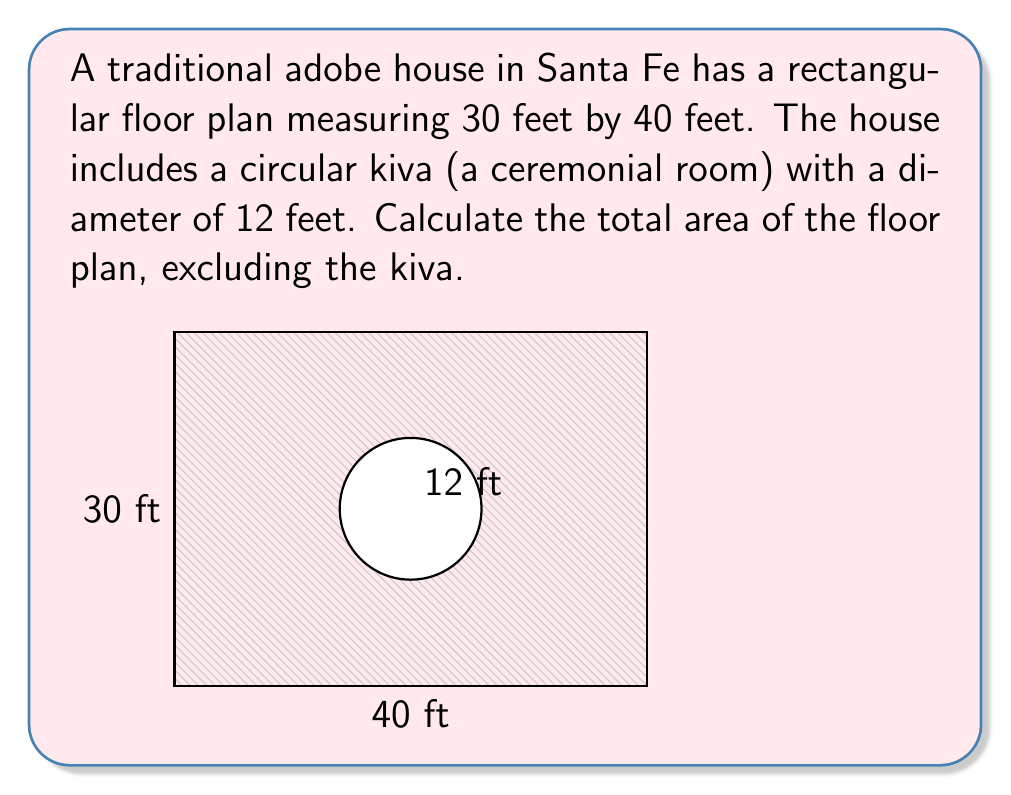Solve this math problem. To solve this problem, we'll follow these steps:

1) Calculate the total area of the rectangular floor plan:
   $$A_{rectangle} = length \times width = 40 \text{ ft} \times 30 \text{ ft} = 1200 \text{ sq ft}$$

2) Calculate the area of the circular kiva:
   $$A_{circle} = \pi r^2$$
   where $r$ is the radius, which is half the diameter.
   $$r = 12 \text{ ft} \div 2 = 6 \text{ ft}$$
   $$A_{circle} = \pi (6 \text{ ft})^2 = 36\pi \text{ sq ft} \approx 113.10 \text{ sq ft}$$

3) Subtract the area of the kiva from the total rectangular area:
   $$A_{total} = A_{rectangle} - A_{circle}$$
   $$A_{total} = 1200 \text{ sq ft} - 36\pi \text{ sq ft}$$
   $$A_{total} = 1200 - 36\pi \text{ sq ft}$$
   $$A_{total} \approx 1086.90 \text{ sq ft}$$

Therefore, the total area of the floor plan, excluding the kiva, is approximately 1086.90 square feet.
Answer: $1200 - 36\pi \text{ sq ft} \approx 1086.90 \text{ sq ft}$ 